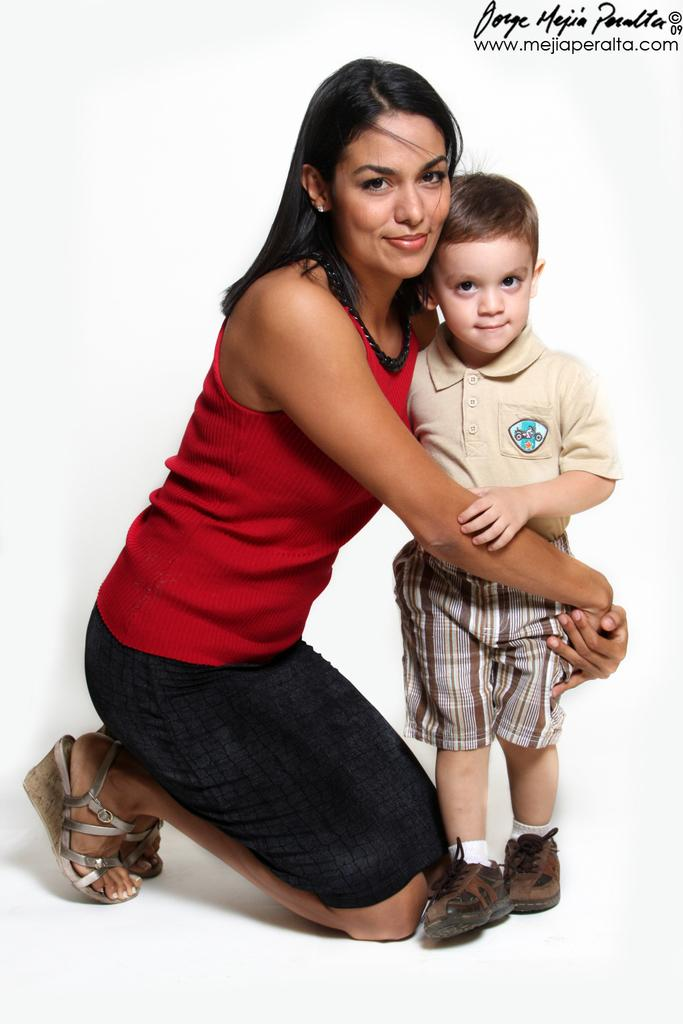What is the person in the image doing? The person in the image is riding a bicycle. What color is the bicycle? The bicycle is blue in color. Can you describe any other objects or animals in the image? There are no other objects or animals mentioned in the transcript. What type of noise can be heard coming from the squirrel in the image? There is no squirrel present in the image, so it is not possible to determine what noise, if any, might be heard. 